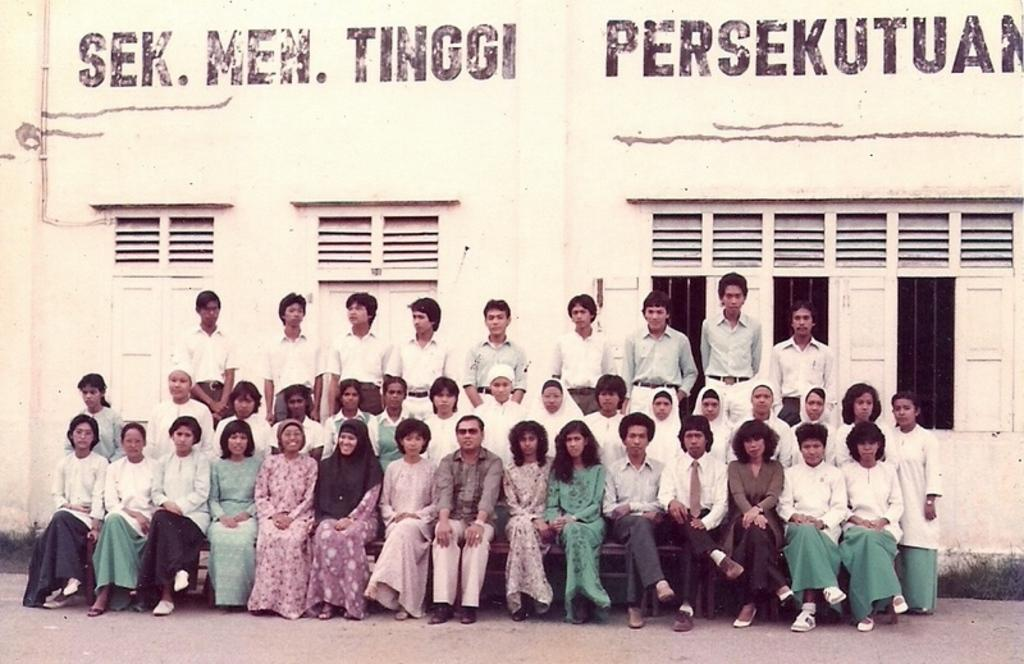What are the persons in the image doing? The persons in the image are sitting on the benches. Are there any other persons visible in the image? Yes, there are persons standing behind the sitting persons in the image. What can be seen in the background of the image? Buildings, windows, pipelines, the ground, and grass are visible in the background of the image. What type of ant can be seen crawling on the grass in the image? There are no ants present in the image; it only features persons sitting and standing, as well as background details. 